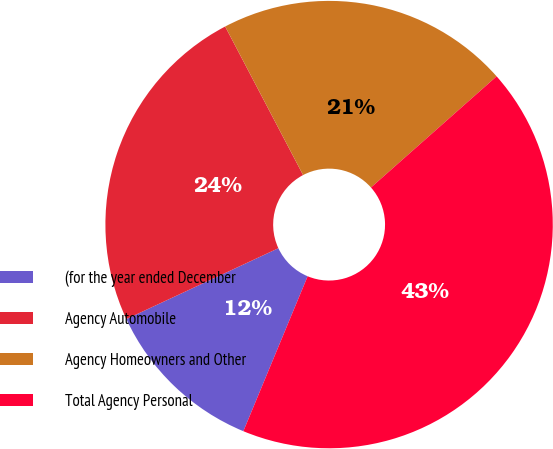Convert chart. <chart><loc_0><loc_0><loc_500><loc_500><pie_chart><fcel>(for the year ended December<fcel>Agency Automobile<fcel>Agency Homeowners and Other<fcel>Total Agency Personal<nl><fcel>11.8%<fcel>24.25%<fcel>21.16%<fcel>42.79%<nl></chart> 